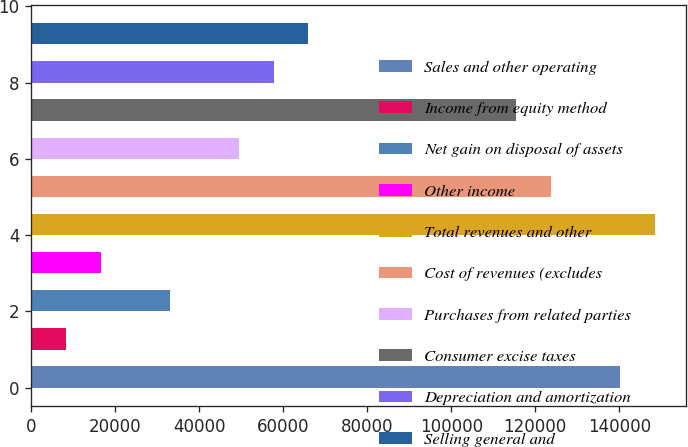<chart> <loc_0><loc_0><loc_500><loc_500><bar_chart><fcel>Sales and other operating<fcel>Income from equity method<fcel>Net gain on disposal of assets<fcel>Other income<fcel>Total revenues and other<fcel>Cost of revenues (excludes<fcel>Purchases from related parties<fcel>Consumer excise taxes<fcel>Depreciation and amortization<fcel>Selling general and<nl><fcel>140234<fcel>8252.8<fcel>32999.2<fcel>16501.6<fcel>148482<fcel>123736<fcel>49496.8<fcel>115487<fcel>57745.6<fcel>65994.4<nl></chart> 